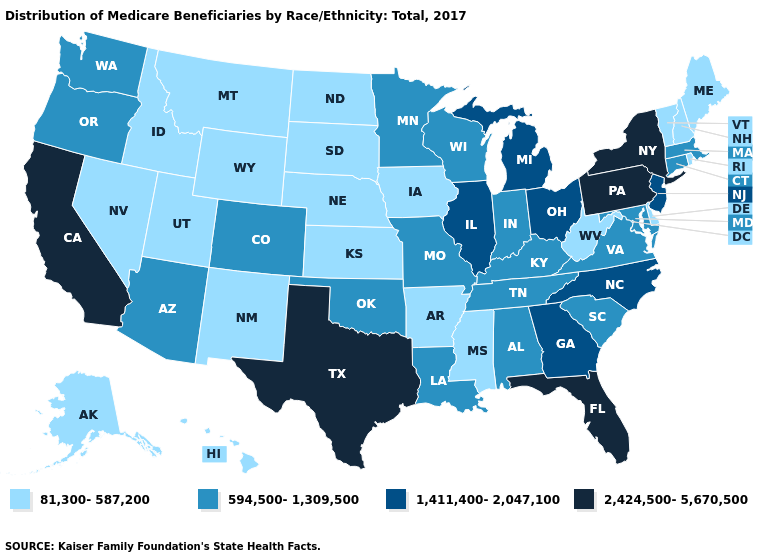What is the value of Illinois?
Concise answer only. 1,411,400-2,047,100. What is the value of Louisiana?
Be succinct. 594,500-1,309,500. Name the states that have a value in the range 2,424,500-5,670,500?
Write a very short answer. California, Florida, New York, Pennsylvania, Texas. What is the lowest value in the USA?
Give a very brief answer. 81,300-587,200. Name the states that have a value in the range 1,411,400-2,047,100?
Be succinct. Georgia, Illinois, Michigan, New Jersey, North Carolina, Ohio. Does Iowa have the highest value in the MidWest?
Short answer required. No. What is the value of Washington?
Quick response, please. 594,500-1,309,500. Does New York have the lowest value in the USA?
Write a very short answer. No. What is the value of Rhode Island?
Write a very short answer. 81,300-587,200. Is the legend a continuous bar?
Answer briefly. No. What is the value of Nebraska?
Give a very brief answer. 81,300-587,200. What is the lowest value in the Northeast?
Write a very short answer. 81,300-587,200. What is the lowest value in the West?
Keep it brief. 81,300-587,200. Name the states that have a value in the range 2,424,500-5,670,500?
Be succinct. California, Florida, New York, Pennsylvania, Texas. What is the value of Arkansas?
Keep it brief. 81,300-587,200. 